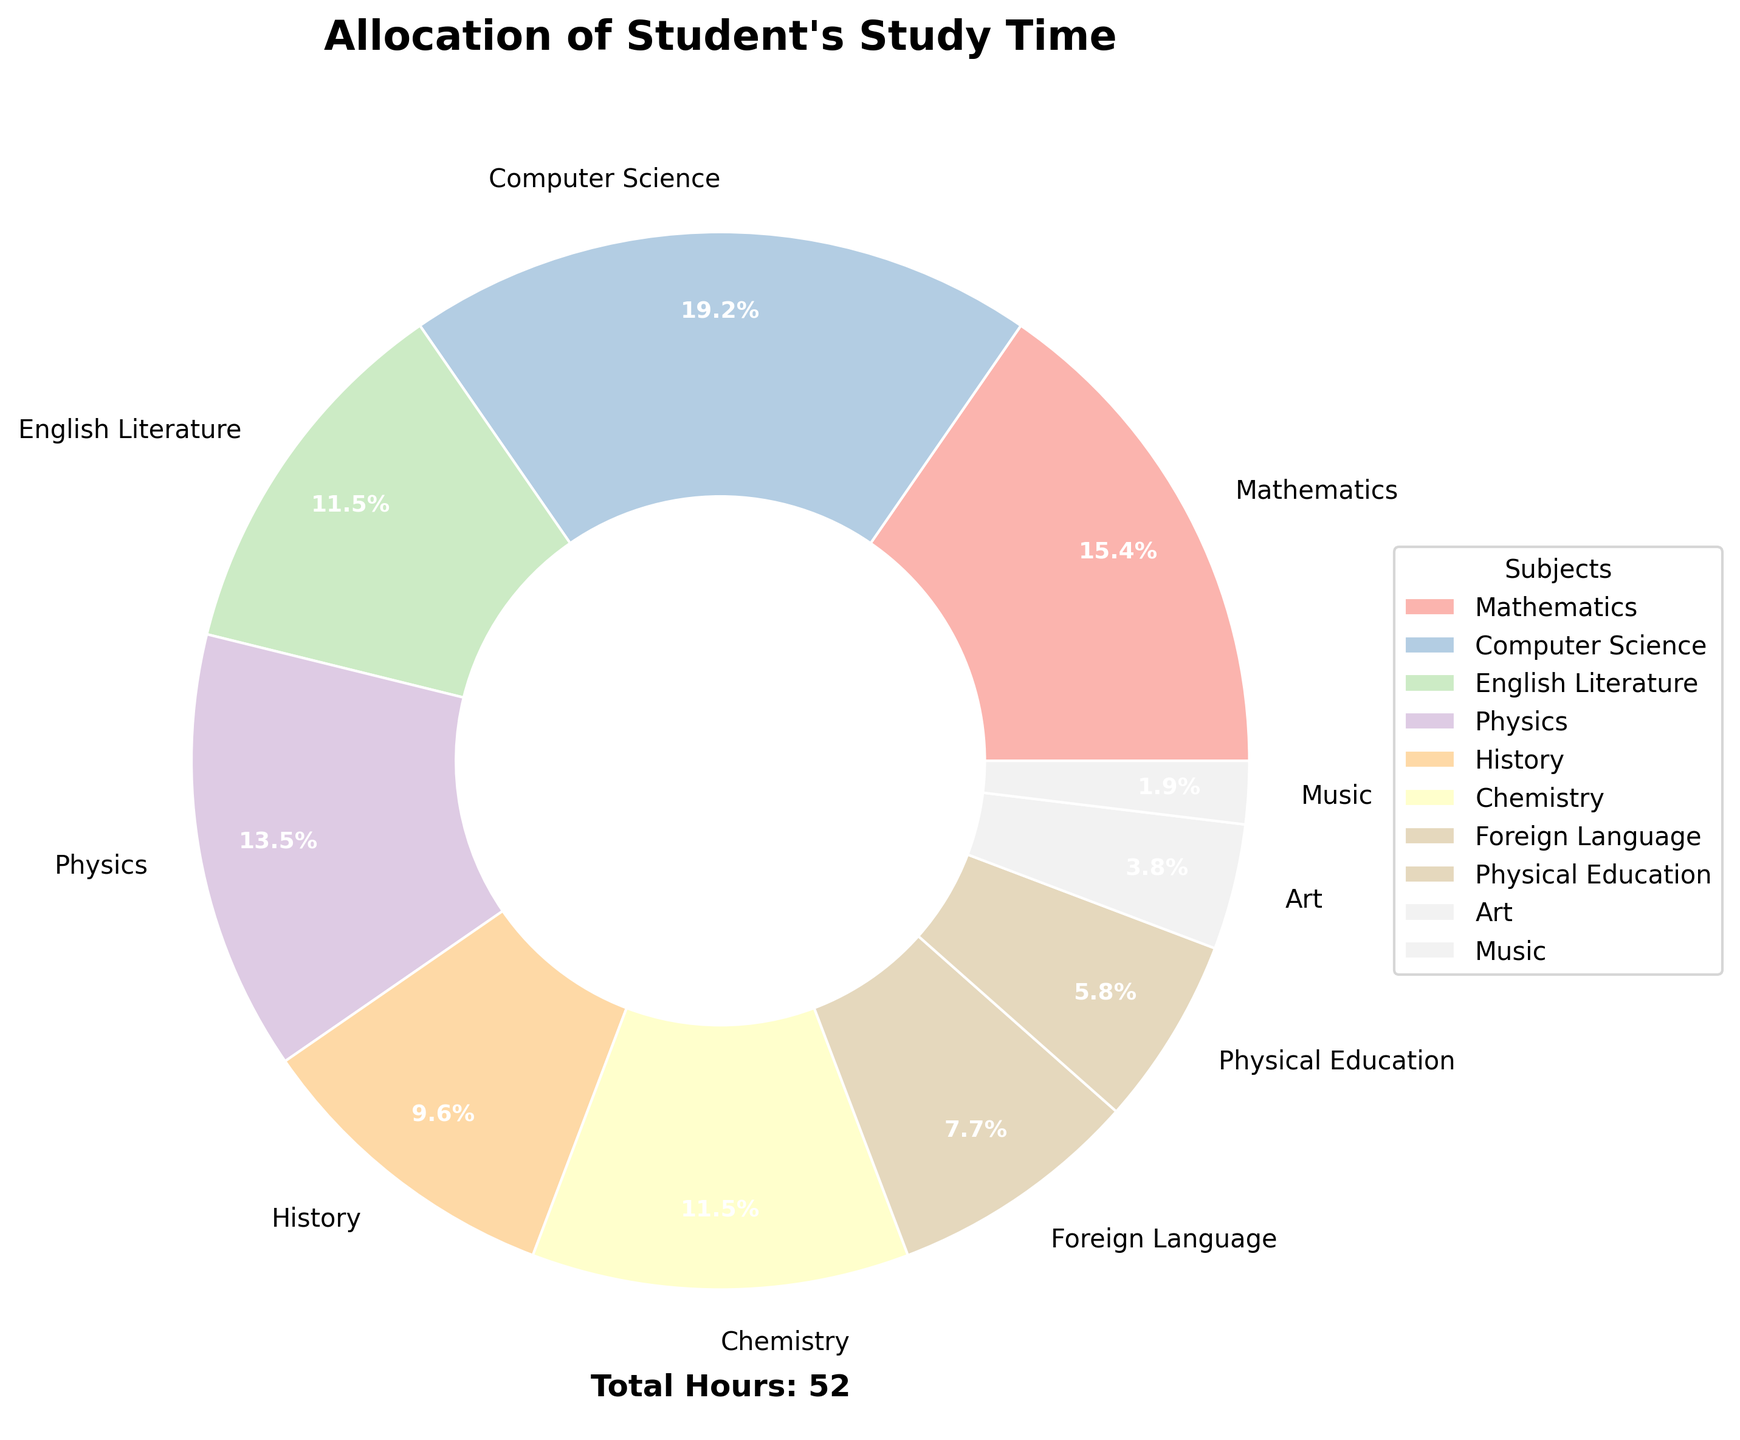What's the subject with the highest study time allocation? Look at the pie chart and identify the subject with the largest wedge. Computer Science has the largest wedge indicating the highest study time allocation.
Answer: Computer Science Which subjects have the same study time allocation? Locate the subjects with wedges of the same size in the pie chart. English Literature and Chemistry both have the same allocation with equal-sized wedges.
Answer: English Literature and Chemistry How many subjects have study time allocations greater than or equal to 7 hours? Count the number of subjects whose wedges correspond to hours greater than or equal to 7 in the pie chart. Mathematics, Computer Science, and Physics each have 7 or more hours allocated.
Answer: 3 What is the total study time allocated to Mathematics, Physics, and Chemistry? Sum the hours allocated to Mathematics (8), Physics (7), and Chemistry (6). The sum is 8 + 7 + 6 = 21 hours.
Answer: 21 hours What percentage of a student's total study time is allocated to art? Check the wedge labeled Art on the pie chart and read the percentage label associated with it. The chart component for Art shows 4.3%.
Answer: 4.3% Which subject has the smallest study time allocation? Identify the subject with the smallest wedge in the pie chart. Music has the smallest wedge, indicating the least study time.
Answer: Music Is the allocation of study time evenly distributed among subjects? Visually inspect all the wedges in the pie chart. They are of varying sizes indicating an uneven distribution of study time among subjects.
Answer: No What subjects combined represent exactly half of the total study time? Identify and add the percentages: Computer Science (18.2%) and Mathematics (21.9%) is 40.1%, then add Physics (15.4%): 40.1% + 15.4% = 55.5%, exceeding half. Going further, English Literature (13.2%) and Chemistry (13.2%) combined is 26.4%; adding Mathematics is 48.3%, and finally considering Physical Education: 48.3% + 7.1% = 55.4%. Thus, no exact 50%, but close.
Answer: None 